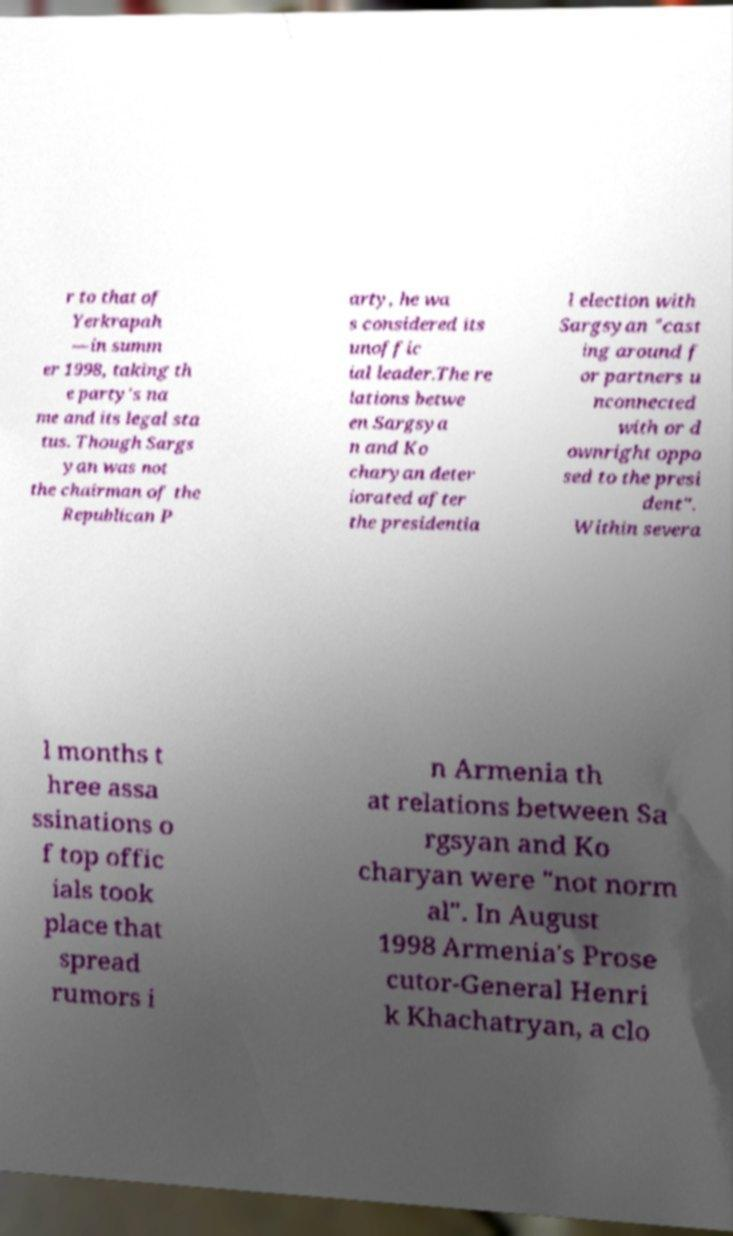For documentation purposes, I need the text within this image transcribed. Could you provide that? r to that of Yerkrapah —in summ er 1998, taking th e party's na me and its legal sta tus. Though Sargs yan was not the chairman of the Republican P arty, he wa s considered its unoffic ial leader.The re lations betwe en Sargsya n and Ko charyan deter iorated after the presidentia l election with Sargsyan "cast ing around f or partners u nconnected with or d ownright oppo sed to the presi dent". Within severa l months t hree assa ssinations o f top offic ials took place that spread rumors i n Armenia th at relations between Sa rgsyan and Ko charyan were "not norm al". In August 1998 Armenia's Prose cutor-General Henri k Khachatryan, a clo 